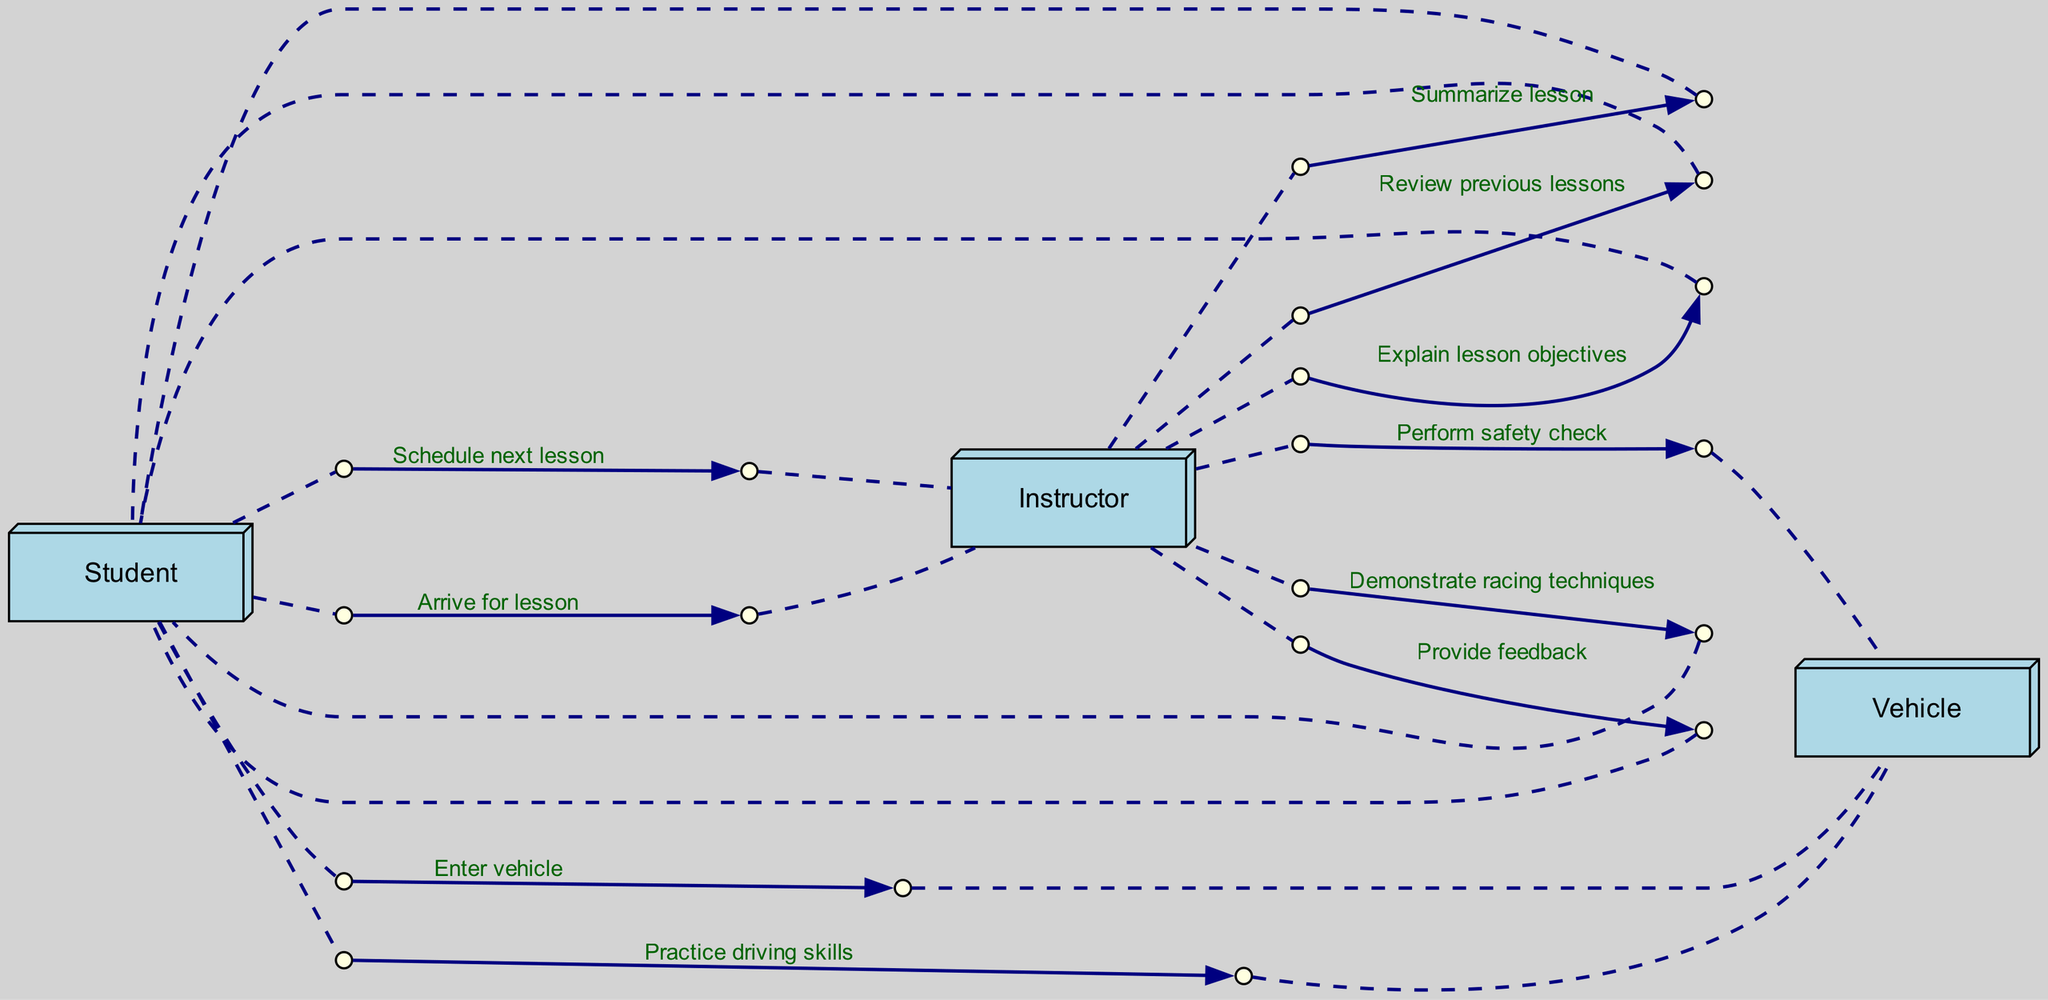What is the first action taken by the student? The first action is the student arriving for the lesson. This is indicated at the beginning of the sequence where the student communicates with the instructor.
Answer: Arrive for lesson Who performs the safety check? The instructor is responsible for performing the safety check on the vehicle, which is shown as a communication from the instructor to the vehicle in the sequence diagram.
Answer: Instructor How many times does the instructor provide feedback? The instructor provides feedback once during the lesson, which is represented as a single communication from the instructor to the student.
Answer: One What are the objectives explained by the instructor? The instructor explains the objectives of the lesson at a specific point in the sequence following the review of previous lessons. This explanation is directly communicated to the student.
Answer: Explain lesson objectives Which actor enters the vehicle during the lesson? The student enters the vehicle, as indicated in the diagram where there is a direct communication from the student to the vehicle.
Answer: Student What happens after the student practices driving skills? After the student practices driving skills, the instructor provides feedback to the student. This sequence is clearly delineated in the diagram.
Answer: Provide feedback In the sequence, how many actors are involved? There are three actors involved, represented as nodes in the sequence diagram: Student, Instructor, and Vehicle.
Answer: Three What is the last action taken in the sequence? The last action is the student scheduling the next lesson with the instructor. This concludes the sequence of events laid out in the diagram.
Answer: Schedule next lesson 